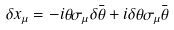Convert formula to latex. <formula><loc_0><loc_0><loc_500><loc_500>\delta x _ { \mu } = - i \theta \sigma _ { \mu } \delta \bar { \theta } + i \delta \theta \sigma _ { \mu } \bar { \theta }</formula> 